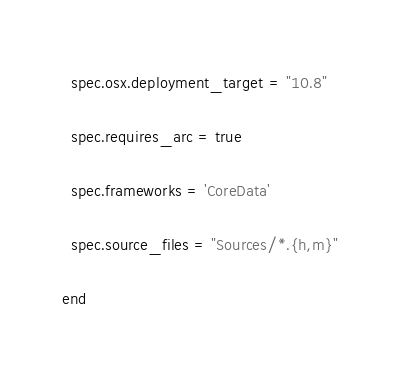<code> <loc_0><loc_0><loc_500><loc_500><_Ruby_>
  spec.osx.deployment_target = "10.8"

  spec.requires_arc = true

  spec.frameworks = 'CoreData'

  spec.source_files = "Sources/*.{h,m}"

end
</code> 